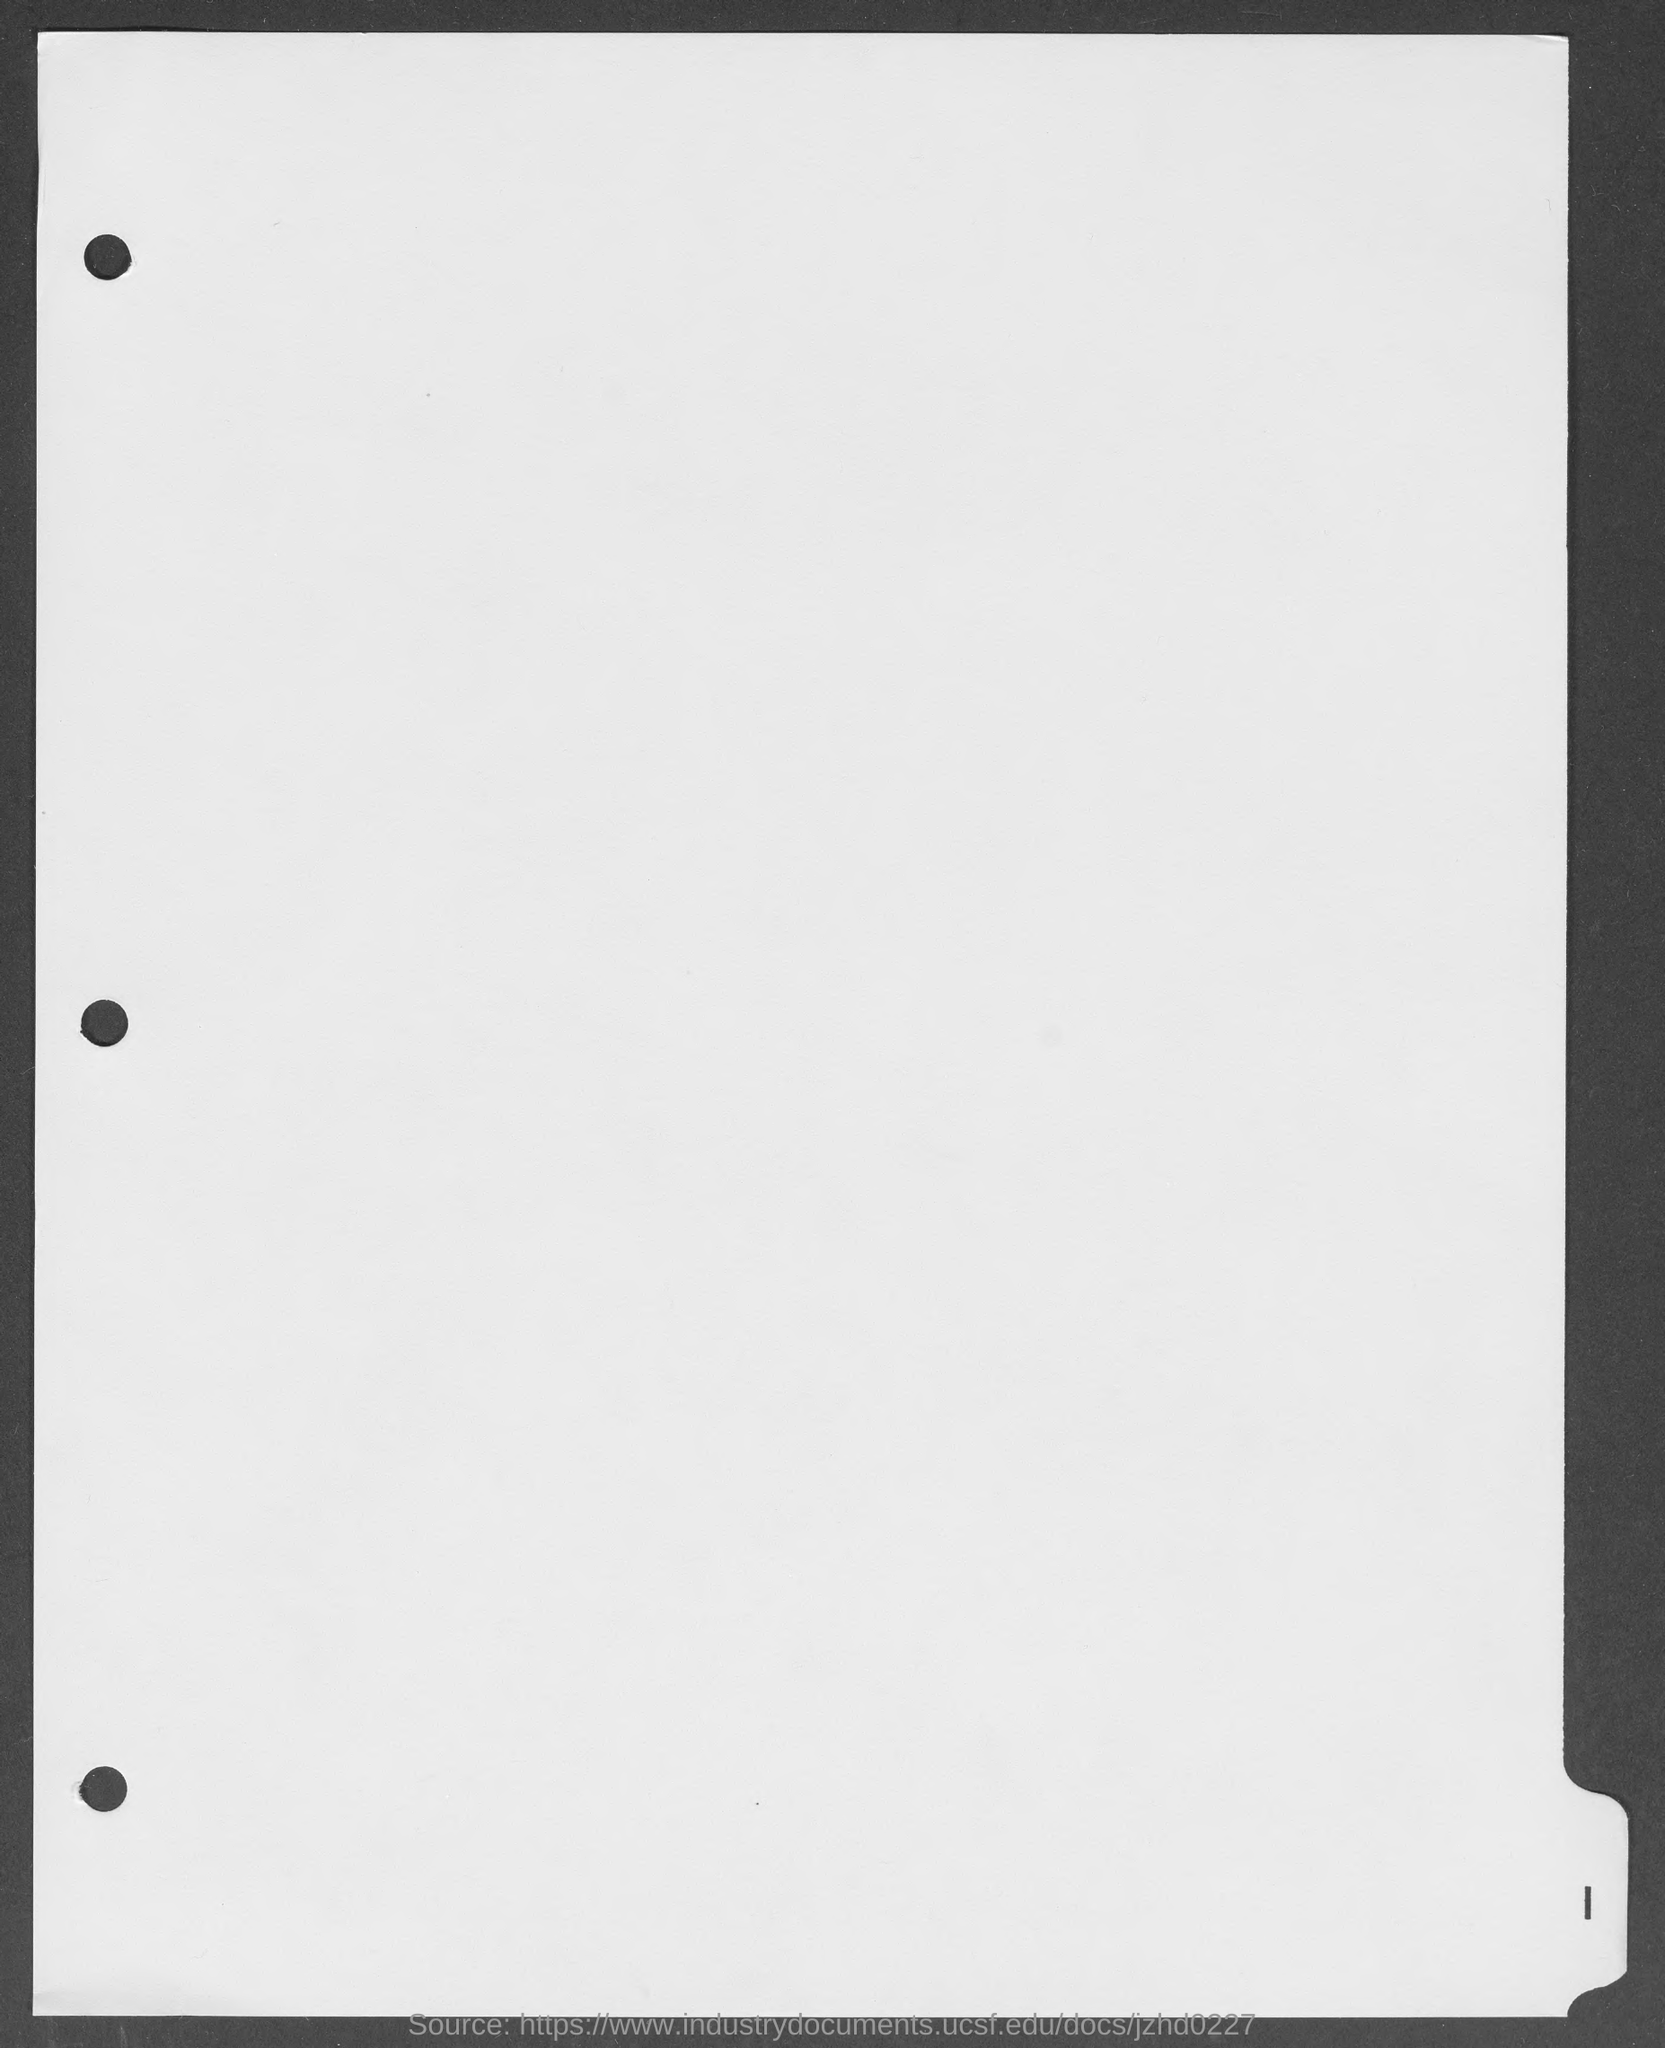What is page number mentioned at right bottom of page?
Provide a short and direct response. 1. 